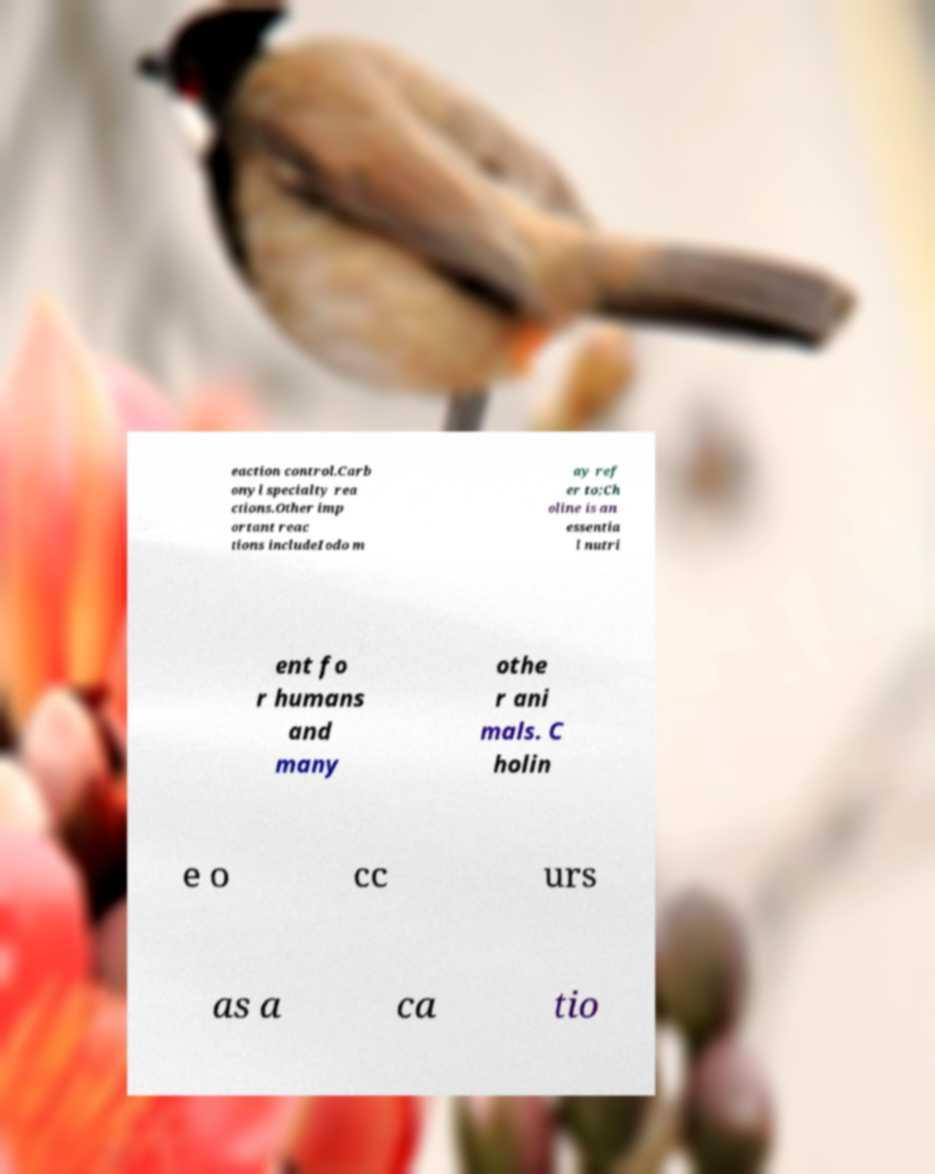For documentation purposes, I need the text within this image transcribed. Could you provide that? eaction control.Carb onyl specialty rea ctions.Other imp ortant reac tions includeIodo m ay ref er to;Ch oline is an essentia l nutri ent fo r humans and many othe r ani mals. C holin e o cc urs as a ca tio 